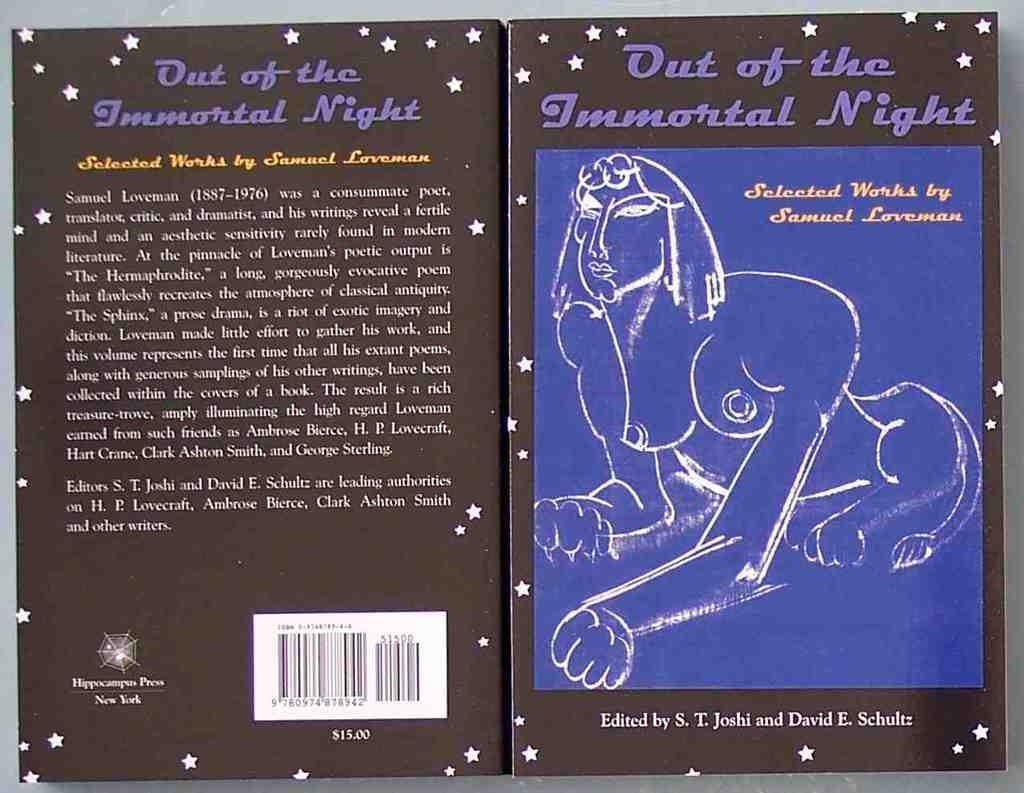<image>
Render a clear and concise summary of the photo. a book that is titled 'out of the immortal night' on it 